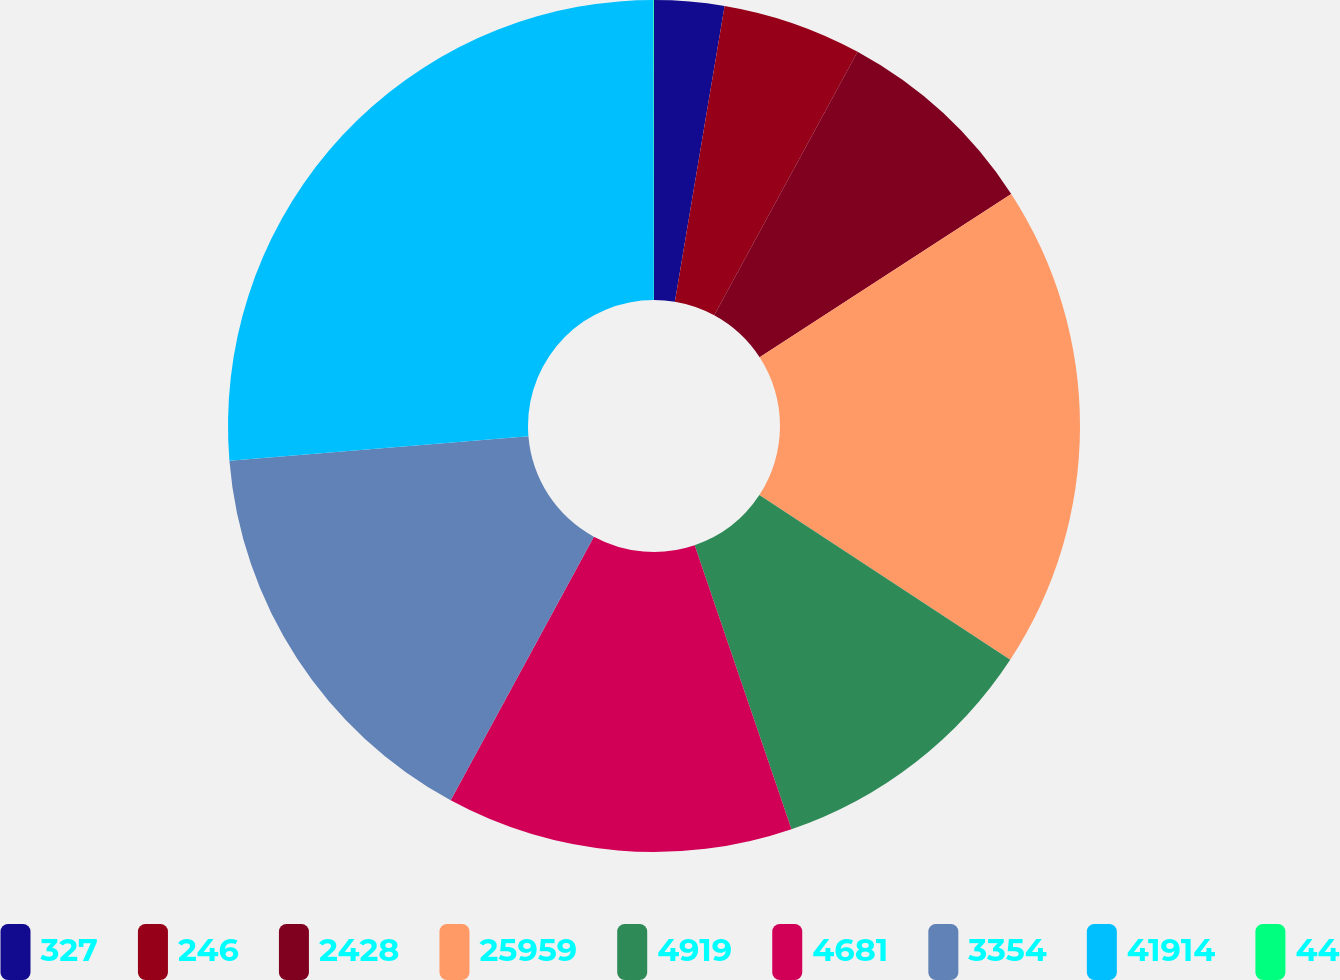Convert chart to OTSL. <chart><loc_0><loc_0><loc_500><loc_500><pie_chart><fcel>327<fcel>246<fcel>2428<fcel>25959<fcel>4919<fcel>4681<fcel>3354<fcel>41914<fcel>44<nl><fcel>2.65%<fcel>5.28%<fcel>7.9%<fcel>18.41%<fcel>10.53%<fcel>13.15%<fcel>15.78%<fcel>26.28%<fcel>0.02%<nl></chart> 